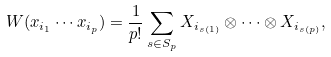<formula> <loc_0><loc_0><loc_500><loc_500>W ( x _ { i _ { 1 } } \cdots x _ { i _ { p } } ) = { \frac { 1 } { p ! } } \sum _ { s \in S _ { p } } X _ { i _ { s ( 1 ) } } \otimes \cdots \otimes X _ { i _ { s ( p ) } } ,</formula> 